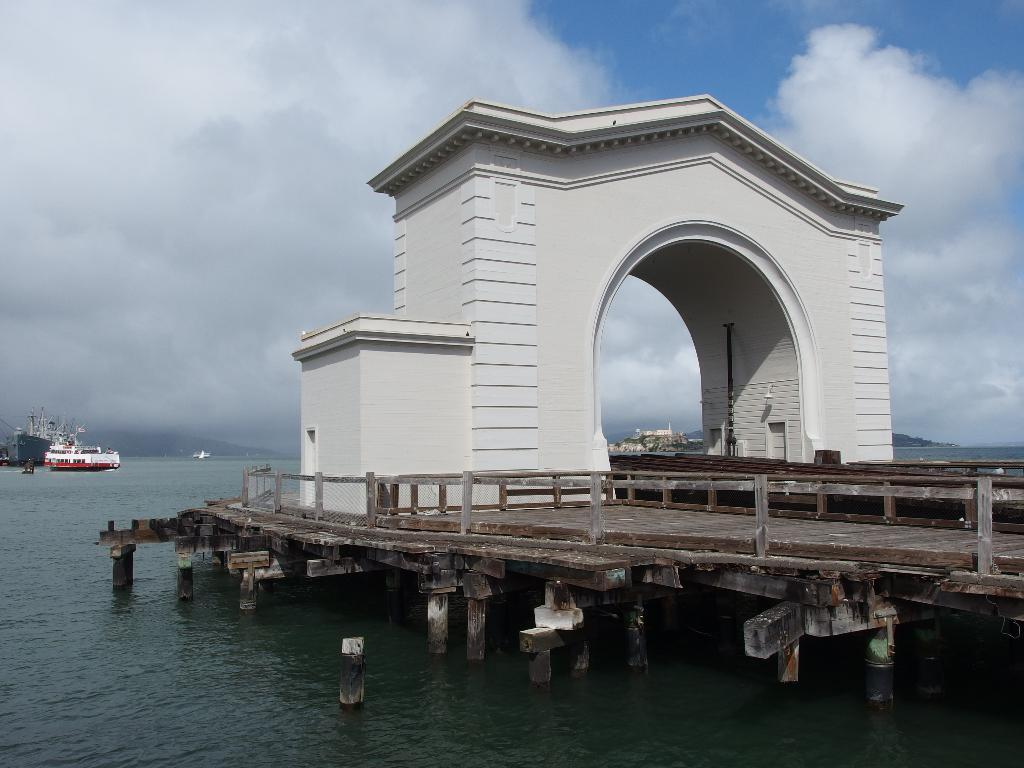What type of structure is located on the right side of the image? There is a wooden bridge on the right side of the image. What feature can be seen on the wooden bridge? There is an arch on the bridge. What can be seen in the background of the image? There is a ship in the water in the background of the image. What is visible at the top of the image? The sky is visible at the top of the image. Can you tell me where the boy is standing on the bridge in the image? There is no boy present in the image; it only features a wooden bridge with an arch and a ship in the background. 